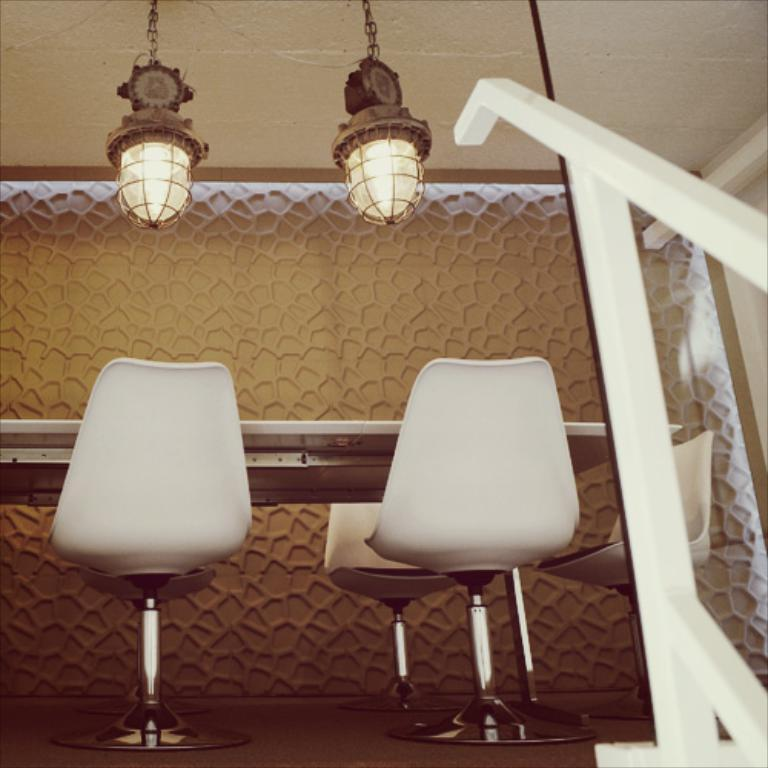What type of furniture is present in the image? There is a table in the image. What is placed on the table's surface? Chairs are placed on the table's surface. What can be seen in the background of the image? There is a wall visible in the image. What type of lighting is present in the image? Ceiling lights are hanged from the roof. What is located on the right side of the image? There is a railing on the right side of the image. In which direction is the boot facing in the image? There is no boot present in the image, so it is not possible to determine the direction it might be facing. 